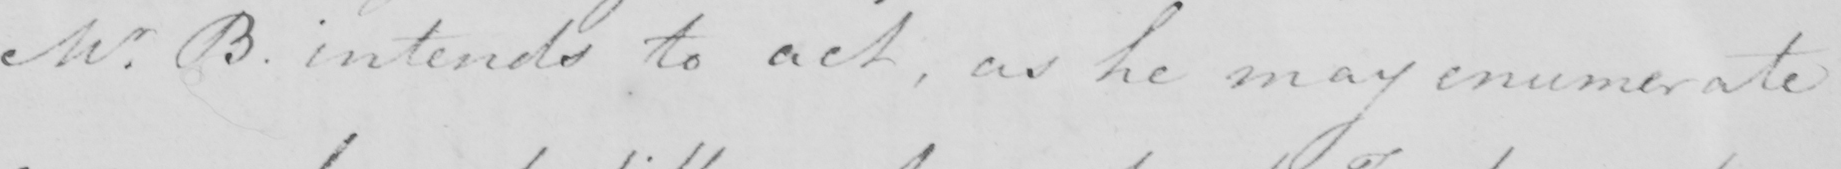What is written in this line of handwriting? Mr . B . intends to act , as he may enumerate 